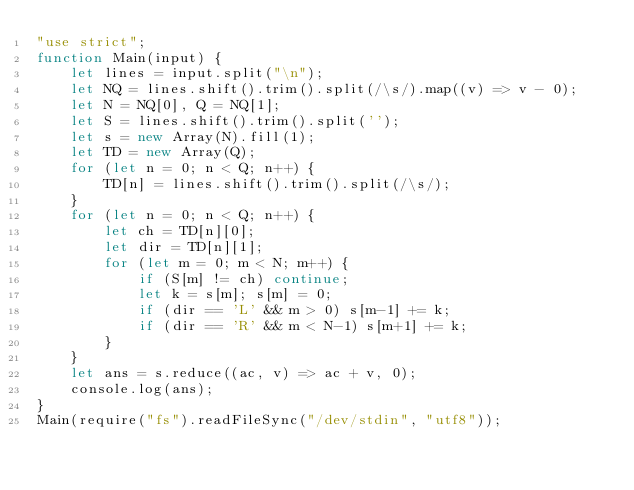Convert code to text. <code><loc_0><loc_0><loc_500><loc_500><_JavaScript_>"use strict";
function Main(input) {
    let lines = input.split("\n");
    let NQ = lines.shift().trim().split(/\s/).map((v) => v - 0);
    let N = NQ[0], Q = NQ[1];
    let S = lines.shift().trim().split('');
    let s = new Array(N).fill(1);
    let TD = new Array(Q);
    for (let n = 0; n < Q; n++) {
        TD[n] = lines.shift().trim().split(/\s/);
    }
    for (let n = 0; n < Q; n++) {
        let ch = TD[n][0];
        let dir = TD[n][1];
        for (let m = 0; m < N; m++) {
            if (S[m] != ch) continue;
            let k = s[m]; s[m] = 0;
            if (dir == 'L' && m > 0) s[m-1] += k;
            if (dir == 'R' && m < N-1) s[m+1] += k;
        }
    }
    let ans = s.reduce((ac, v) => ac + v, 0);
    console.log(ans);
}
Main(require("fs").readFileSync("/dev/stdin", "utf8"));
</code> 